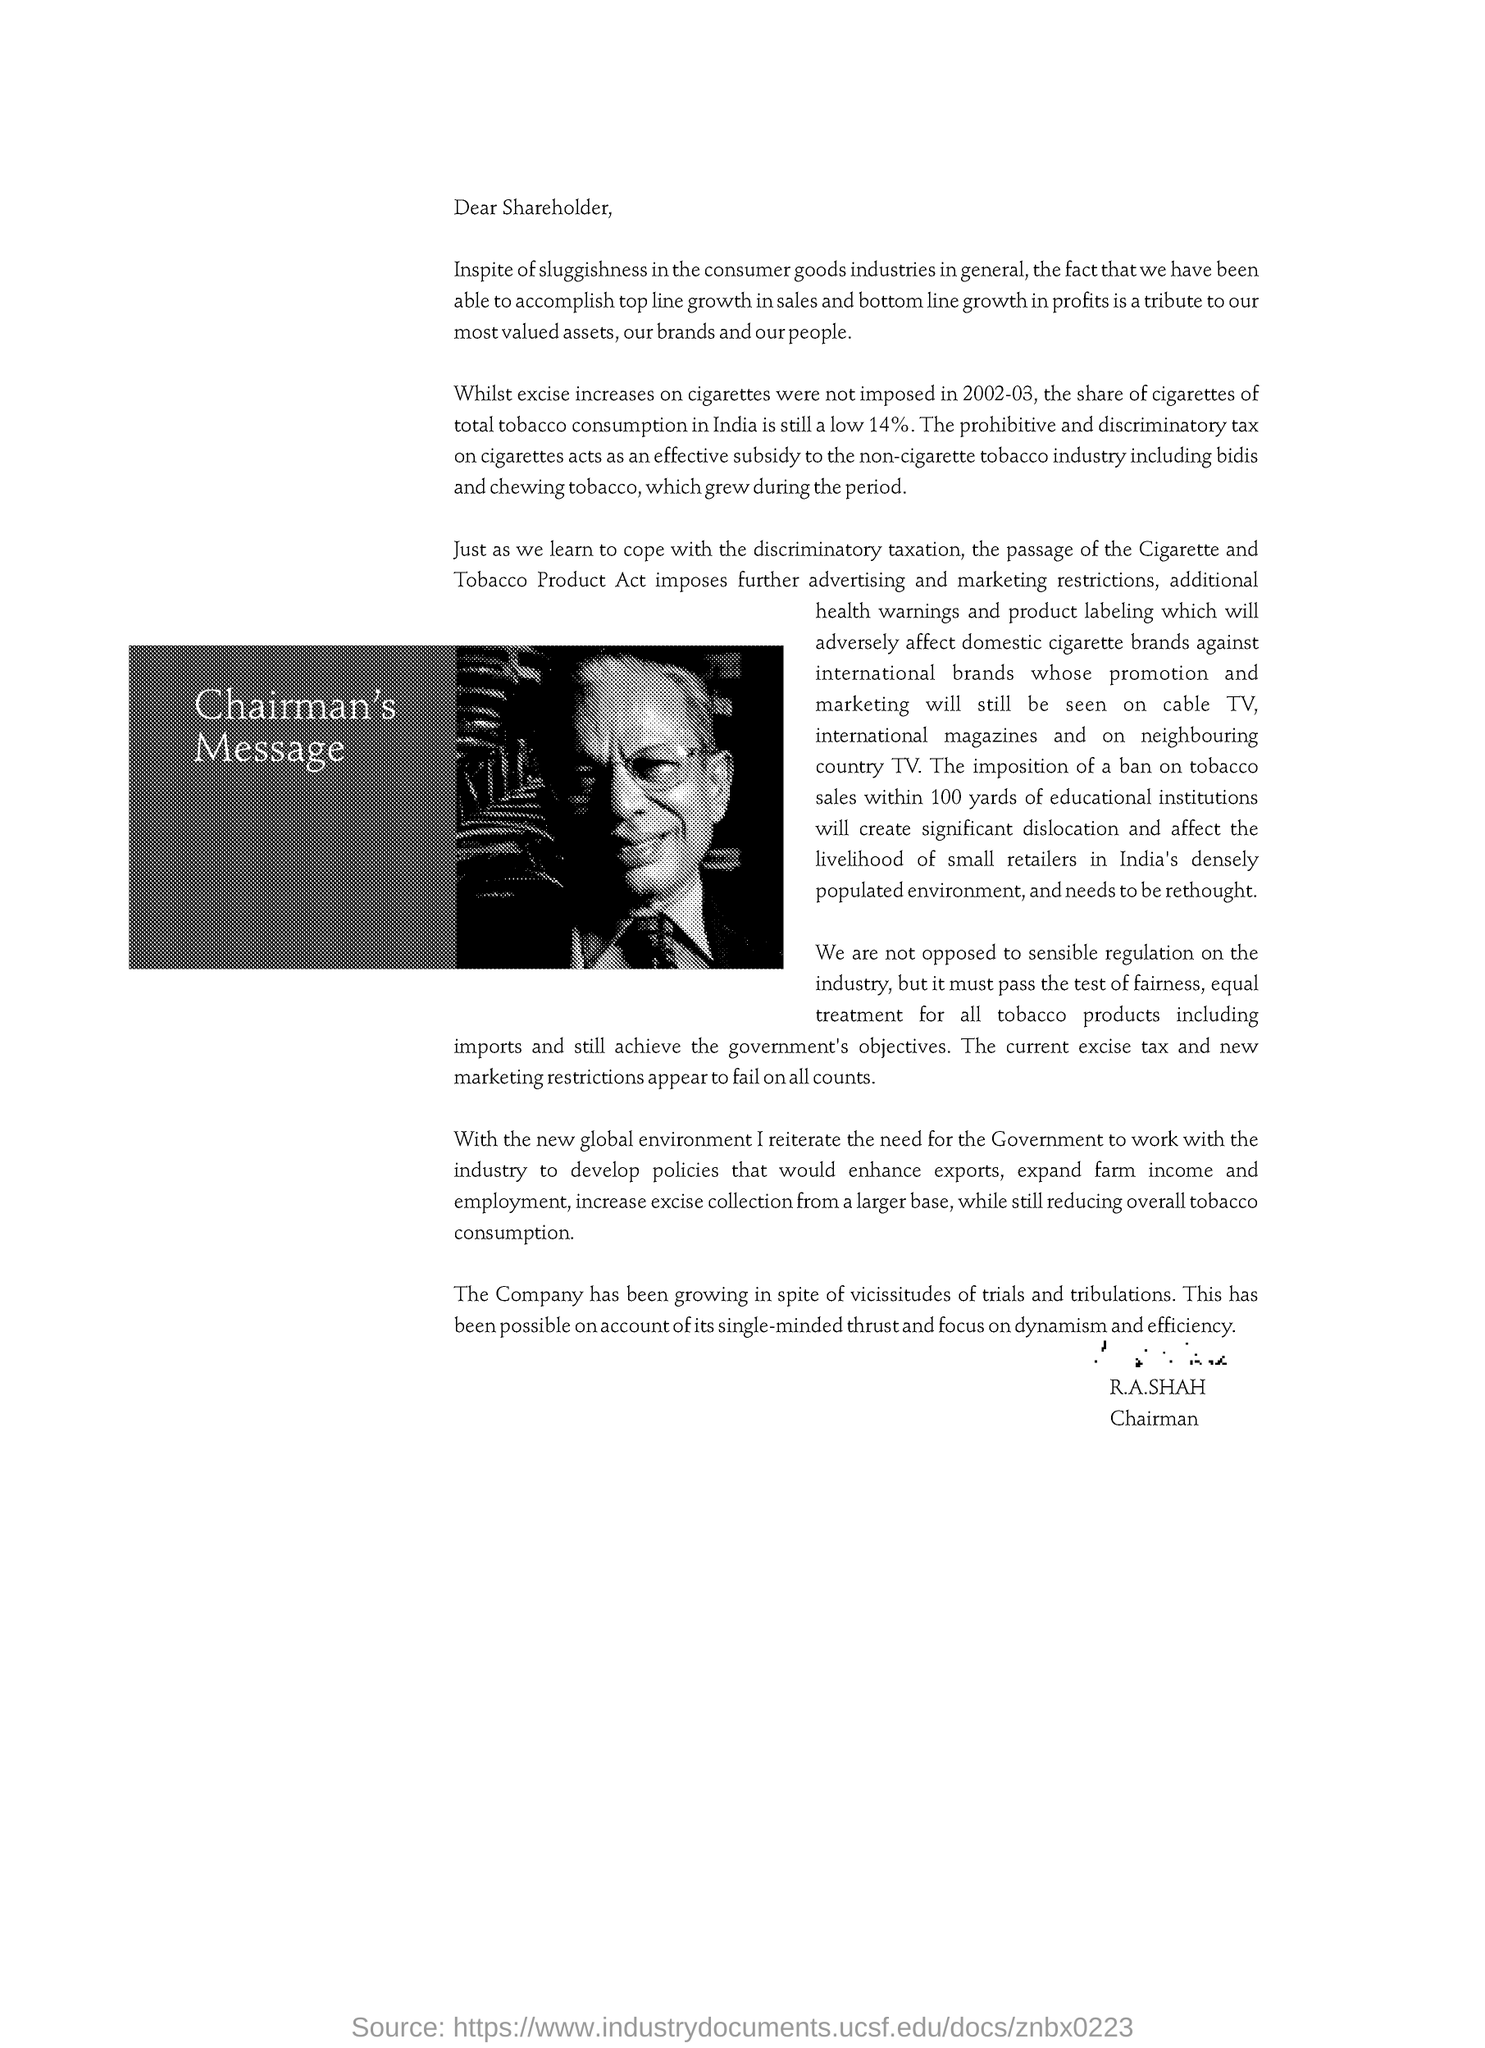Who is the Chairman ?
Your answer should be compact. R.A.SHAH. 